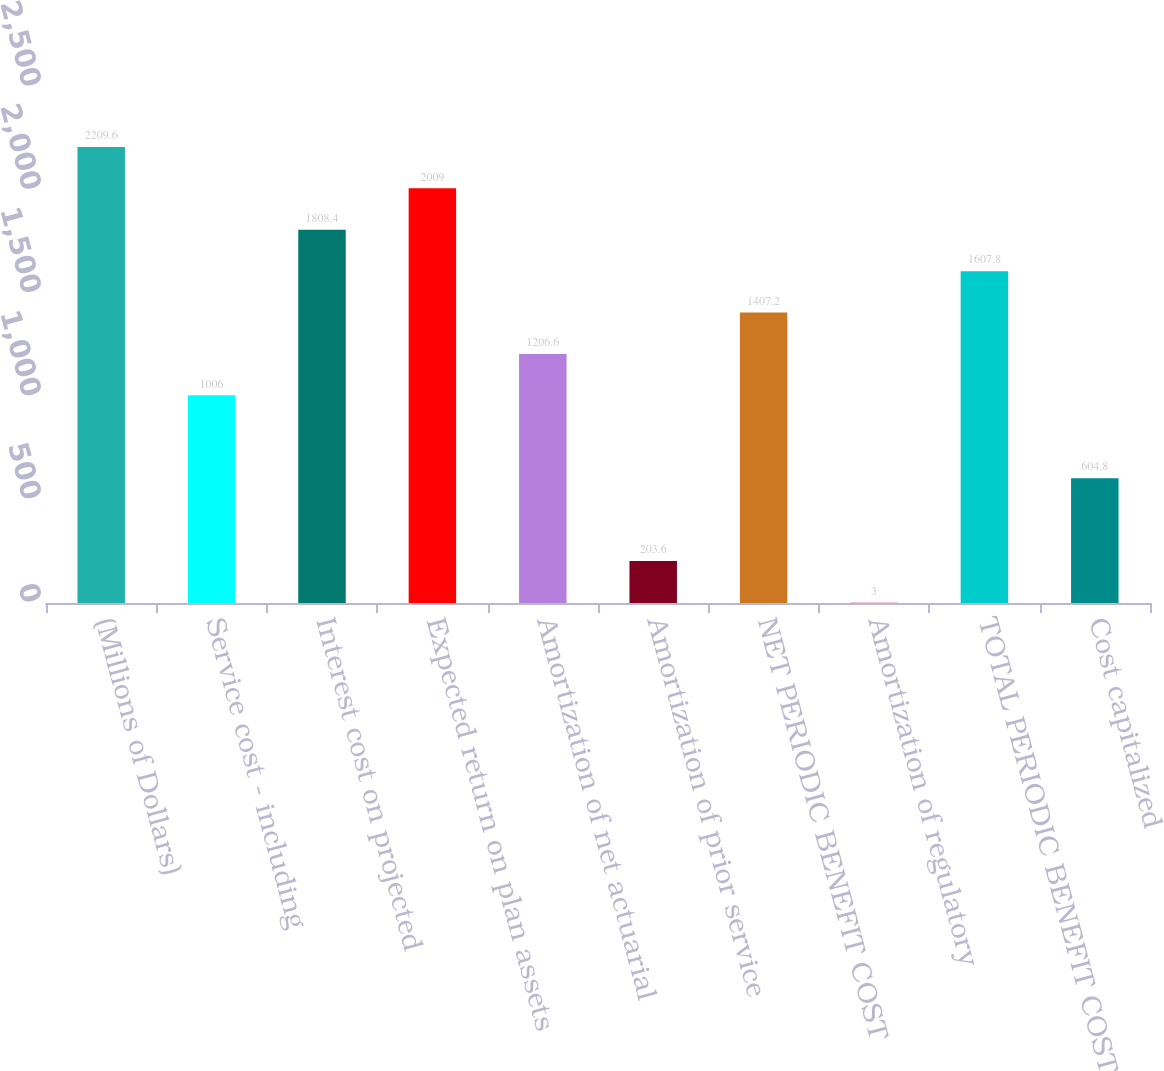Convert chart. <chart><loc_0><loc_0><loc_500><loc_500><bar_chart><fcel>(Millions of Dollars)<fcel>Service cost - including<fcel>Interest cost on projected<fcel>Expected return on plan assets<fcel>Amortization of net actuarial<fcel>Amortization of prior service<fcel>NET PERIODIC BENEFIT COST<fcel>Amortization of regulatory<fcel>TOTAL PERIODIC BENEFIT COST<fcel>Cost capitalized<nl><fcel>2209.6<fcel>1006<fcel>1808.4<fcel>2009<fcel>1206.6<fcel>203.6<fcel>1407.2<fcel>3<fcel>1607.8<fcel>604.8<nl></chart> 